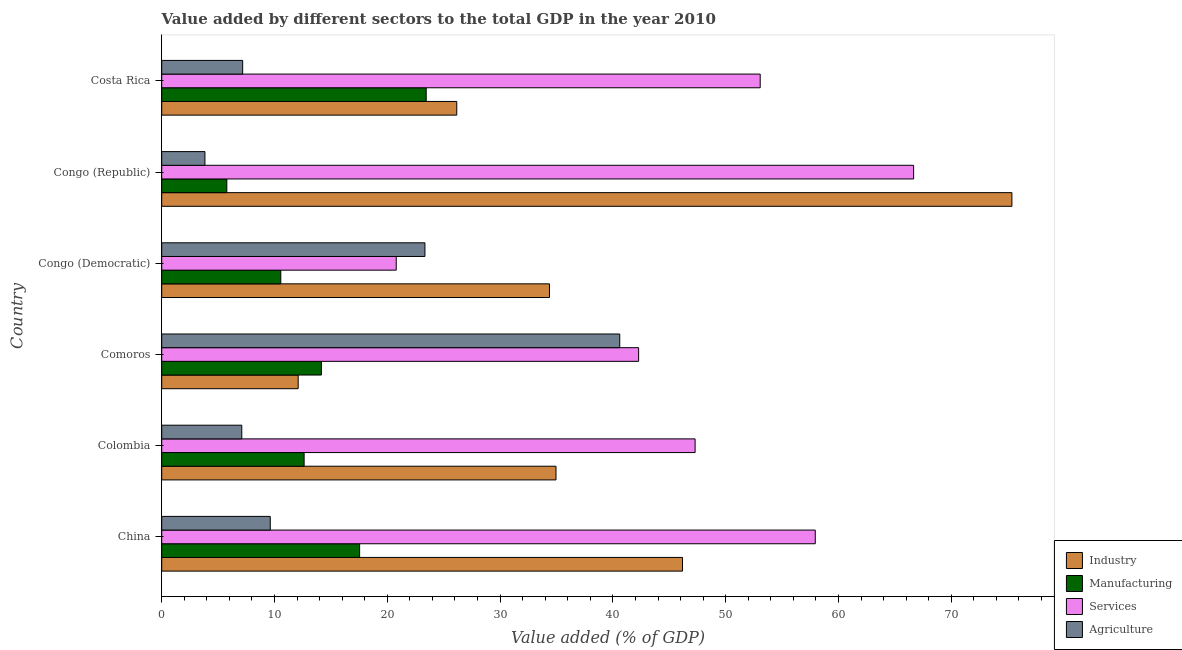Are the number of bars per tick equal to the number of legend labels?
Your answer should be compact. Yes. How many bars are there on the 4th tick from the bottom?
Provide a succinct answer. 4. What is the label of the 1st group of bars from the top?
Make the answer very short. Costa Rica. In how many cases, is the number of bars for a given country not equal to the number of legend labels?
Ensure brevity in your answer.  0. What is the value added by agricultural sector in China?
Offer a terse response. 9.62. Across all countries, what is the maximum value added by services sector?
Offer a terse response. 66.66. Across all countries, what is the minimum value added by services sector?
Your answer should be very brief. 20.79. In which country was the value added by industrial sector maximum?
Your answer should be compact. Congo (Republic). In which country was the value added by industrial sector minimum?
Ensure brevity in your answer.  Comoros. What is the total value added by manufacturing sector in the graph?
Make the answer very short. 84.11. What is the difference between the value added by agricultural sector in Colombia and that in Congo (Republic)?
Your answer should be compact. 3.27. What is the difference between the value added by services sector in China and the value added by agricultural sector in Comoros?
Your answer should be compact. 17.33. What is the average value added by services sector per country?
Offer a very short reply. 48.01. What is the difference between the value added by services sector and value added by industrial sector in Congo (Republic)?
Your answer should be very brief. -8.71. What is the ratio of the value added by industrial sector in Congo (Democratic) to that in Congo (Republic)?
Your answer should be compact. 0.46. Is the difference between the value added by industrial sector in Colombia and Congo (Republic) greater than the difference between the value added by services sector in Colombia and Congo (Republic)?
Offer a terse response. No. What is the difference between the highest and the second highest value added by industrial sector?
Offer a very short reply. 29.2. What is the difference between the highest and the lowest value added by agricultural sector?
Ensure brevity in your answer.  36.78. In how many countries, is the value added by industrial sector greater than the average value added by industrial sector taken over all countries?
Provide a short and direct response. 2. Is the sum of the value added by agricultural sector in Colombia and Comoros greater than the maximum value added by industrial sector across all countries?
Provide a succinct answer. No. What does the 3rd bar from the top in Colombia represents?
Your answer should be compact. Manufacturing. What does the 2nd bar from the bottom in Costa Rica represents?
Make the answer very short. Manufacturing. Is it the case that in every country, the sum of the value added by industrial sector and value added by manufacturing sector is greater than the value added by services sector?
Provide a short and direct response. No. How many countries are there in the graph?
Provide a succinct answer. 6. What is the difference between two consecutive major ticks on the X-axis?
Your response must be concise. 10. Are the values on the major ticks of X-axis written in scientific E-notation?
Offer a terse response. No. Does the graph contain grids?
Give a very brief answer. No. How many legend labels are there?
Your answer should be very brief. 4. How are the legend labels stacked?
Your answer should be very brief. Vertical. What is the title of the graph?
Provide a short and direct response. Value added by different sectors to the total GDP in the year 2010. Does "Taxes on goods and services" appear as one of the legend labels in the graph?
Keep it short and to the point. No. What is the label or title of the X-axis?
Your answer should be very brief. Value added (% of GDP). What is the Value added (% of GDP) of Industry in China?
Make the answer very short. 46.17. What is the Value added (% of GDP) of Manufacturing in China?
Give a very brief answer. 17.55. What is the Value added (% of GDP) of Services in China?
Offer a terse response. 57.94. What is the Value added (% of GDP) in Agriculture in China?
Provide a succinct answer. 9.62. What is the Value added (% of GDP) of Industry in Colombia?
Give a very brief answer. 34.96. What is the Value added (% of GDP) in Manufacturing in Colombia?
Your answer should be very brief. 12.63. What is the Value added (% of GDP) in Services in Colombia?
Your response must be concise. 47.29. What is the Value added (% of GDP) of Agriculture in Colombia?
Your answer should be very brief. 7.1. What is the Value added (% of GDP) in Industry in Comoros?
Provide a short and direct response. 12.1. What is the Value added (% of GDP) of Manufacturing in Comoros?
Your answer should be very brief. 14.16. What is the Value added (% of GDP) of Services in Comoros?
Provide a succinct answer. 42.28. What is the Value added (% of GDP) of Agriculture in Comoros?
Provide a succinct answer. 40.61. What is the Value added (% of GDP) of Industry in Congo (Democratic)?
Provide a succinct answer. 34.38. What is the Value added (% of GDP) of Manufacturing in Congo (Democratic)?
Your response must be concise. 10.56. What is the Value added (% of GDP) of Services in Congo (Democratic)?
Provide a short and direct response. 20.79. What is the Value added (% of GDP) in Agriculture in Congo (Democratic)?
Your answer should be very brief. 23.34. What is the Value added (% of GDP) of Industry in Congo (Republic)?
Make the answer very short. 75.38. What is the Value added (% of GDP) of Manufacturing in Congo (Republic)?
Provide a succinct answer. 5.77. What is the Value added (% of GDP) in Services in Congo (Republic)?
Provide a succinct answer. 66.66. What is the Value added (% of GDP) in Agriculture in Congo (Republic)?
Keep it short and to the point. 3.83. What is the Value added (% of GDP) in Industry in Costa Rica?
Give a very brief answer. 26.16. What is the Value added (% of GDP) of Manufacturing in Costa Rica?
Offer a very short reply. 23.45. What is the Value added (% of GDP) in Services in Costa Rica?
Your answer should be compact. 53.06. What is the Value added (% of GDP) in Agriculture in Costa Rica?
Your answer should be very brief. 7.18. Across all countries, what is the maximum Value added (% of GDP) of Industry?
Give a very brief answer. 75.38. Across all countries, what is the maximum Value added (% of GDP) in Manufacturing?
Make the answer very short. 23.45. Across all countries, what is the maximum Value added (% of GDP) in Services?
Keep it short and to the point. 66.66. Across all countries, what is the maximum Value added (% of GDP) in Agriculture?
Keep it short and to the point. 40.61. Across all countries, what is the minimum Value added (% of GDP) of Industry?
Offer a very short reply. 12.1. Across all countries, what is the minimum Value added (% of GDP) of Manufacturing?
Your response must be concise. 5.77. Across all countries, what is the minimum Value added (% of GDP) in Services?
Make the answer very short. 20.79. Across all countries, what is the minimum Value added (% of GDP) in Agriculture?
Your answer should be very brief. 3.83. What is the total Value added (% of GDP) of Industry in the graph?
Your answer should be very brief. 229.15. What is the total Value added (% of GDP) of Manufacturing in the graph?
Offer a very short reply. 84.11. What is the total Value added (% of GDP) of Services in the graph?
Your response must be concise. 288.04. What is the total Value added (% of GDP) in Agriculture in the graph?
Provide a succinct answer. 91.68. What is the difference between the Value added (% of GDP) of Industry in China and that in Colombia?
Keep it short and to the point. 11.22. What is the difference between the Value added (% of GDP) of Manufacturing in China and that in Colombia?
Make the answer very short. 4.92. What is the difference between the Value added (% of GDP) in Services in China and that in Colombia?
Make the answer very short. 10.65. What is the difference between the Value added (% of GDP) in Agriculture in China and that in Colombia?
Provide a succinct answer. 2.53. What is the difference between the Value added (% of GDP) of Industry in China and that in Comoros?
Provide a short and direct response. 34.07. What is the difference between the Value added (% of GDP) of Manufacturing in China and that in Comoros?
Keep it short and to the point. 3.39. What is the difference between the Value added (% of GDP) of Services in China and that in Comoros?
Your answer should be compact. 15.66. What is the difference between the Value added (% of GDP) of Agriculture in China and that in Comoros?
Your answer should be compact. -30.99. What is the difference between the Value added (% of GDP) of Industry in China and that in Congo (Democratic)?
Give a very brief answer. 11.79. What is the difference between the Value added (% of GDP) of Manufacturing in China and that in Congo (Democratic)?
Make the answer very short. 6.99. What is the difference between the Value added (% of GDP) of Services in China and that in Congo (Democratic)?
Provide a succinct answer. 37.15. What is the difference between the Value added (% of GDP) in Agriculture in China and that in Congo (Democratic)?
Your answer should be very brief. -13.71. What is the difference between the Value added (% of GDP) of Industry in China and that in Congo (Republic)?
Provide a succinct answer. -29.2. What is the difference between the Value added (% of GDP) in Manufacturing in China and that in Congo (Republic)?
Offer a very short reply. 11.77. What is the difference between the Value added (% of GDP) in Services in China and that in Congo (Republic)?
Your response must be concise. -8.72. What is the difference between the Value added (% of GDP) in Agriculture in China and that in Congo (Republic)?
Make the answer very short. 5.79. What is the difference between the Value added (% of GDP) in Industry in China and that in Costa Rica?
Give a very brief answer. 20.02. What is the difference between the Value added (% of GDP) in Manufacturing in China and that in Costa Rica?
Ensure brevity in your answer.  -5.9. What is the difference between the Value added (% of GDP) in Services in China and that in Costa Rica?
Provide a succinct answer. 4.88. What is the difference between the Value added (% of GDP) of Agriculture in China and that in Costa Rica?
Ensure brevity in your answer.  2.45. What is the difference between the Value added (% of GDP) in Industry in Colombia and that in Comoros?
Ensure brevity in your answer.  22.86. What is the difference between the Value added (% of GDP) of Manufacturing in Colombia and that in Comoros?
Provide a succinct answer. -1.53. What is the difference between the Value added (% of GDP) of Services in Colombia and that in Comoros?
Give a very brief answer. 5.01. What is the difference between the Value added (% of GDP) in Agriculture in Colombia and that in Comoros?
Ensure brevity in your answer.  -33.51. What is the difference between the Value added (% of GDP) of Industry in Colombia and that in Congo (Democratic)?
Your answer should be very brief. 0.58. What is the difference between the Value added (% of GDP) in Manufacturing in Colombia and that in Congo (Democratic)?
Offer a very short reply. 2.07. What is the difference between the Value added (% of GDP) in Services in Colombia and that in Congo (Democratic)?
Offer a very short reply. 26.5. What is the difference between the Value added (% of GDP) of Agriculture in Colombia and that in Congo (Democratic)?
Offer a terse response. -16.24. What is the difference between the Value added (% of GDP) in Industry in Colombia and that in Congo (Republic)?
Your response must be concise. -40.42. What is the difference between the Value added (% of GDP) of Manufacturing in Colombia and that in Congo (Republic)?
Ensure brevity in your answer.  6.85. What is the difference between the Value added (% of GDP) of Services in Colombia and that in Congo (Republic)?
Provide a short and direct response. -19.37. What is the difference between the Value added (% of GDP) of Agriculture in Colombia and that in Congo (Republic)?
Offer a terse response. 3.27. What is the difference between the Value added (% of GDP) of Industry in Colombia and that in Costa Rica?
Offer a terse response. 8.8. What is the difference between the Value added (% of GDP) of Manufacturing in Colombia and that in Costa Rica?
Ensure brevity in your answer.  -10.82. What is the difference between the Value added (% of GDP) of Services in Colombia and that in Costa Rica?
Keep it short and to the point. -5.77. What is the difference between the Value added (% of GDP) of Agriculture in Colombia and that in Costa Rica?
Offer a terse response. -0.08. What is the difference between the Value added (% of GDP) of Industry in Comoros and that in Congo (Democratic)?
Your answer should be compact. -22.28. What is the difference between the Value added (% of GDP) of Manufacturing in Comoros and that in Congo (Democratic)?
Your answer should be very brief. 3.6. What is the difference between the Value added (% of GDP) of Services in Comoros and that in Congo (Democratic)?
Keep it short and to the point. 21.49. What is the difference between the Value added (% of GDP) in Agriculture in Comoros and that in Congo (Democratic)?
Offer a very short reply. 17.27. What is the difference between the Value added (% of GDP) in Industry in Comoros and that in Congo (Republic)?
Ensure brevity in your answer.  -63.28. What is the difference between the Value added (% of GDP) in Manufacturing in Comoros and that in Congo (Republic)?
Keep it short and to the point. 8.38. What is the difference between the Value added (% of GDP) in Services in Comoros and that in Congo (Republic)?
Provide a succinct answer. -24.38. What is the difference between the Value added (% of GDP) in Agriculture in Comoros and that in Congo (Republic)?
Your answer should be very brief. 36.78. What is the difference between the Value added (% of GDP) of Industry in Comoros and that in Costa Rica?
Keep it short and to the point. -14.06. What is the difference between the Value added (% of GDP) of Manufacturing in Comoros and that in Costa Rica?
Your answer should be very brief. -9.29. What is the difference between the Value added (% of GDP) of Services in Comoros and that in Costa Rica?
Your response must be concise. -10.78. What is the difference between the Value added (% of GDP) in Agriculture in Comoros and that in Costa Rica?
Provide a short and direct response. 33.43. What is the difference between the Value added (% of GDP) in Industry in Congo (Democratic) and that in Congo (Republic)?
Provide a short and direct response. -41. What is the difference between the Value added (% of GDP) in Manufacturing in Congo (Democratic) and that in Congo (Republic)?
Give a very brief answer. 4.78. What is the difference between the Value added (% of GDP) in Services in Congo (Democratic) and that in Congo (Republic)?
Offer a very short reply. -45.87. What is the difference between the Value added (% of GDP) of Agriculture in Congo (Democratic) and that in Congo (Republic)?
Offer a very short reply. 19.51. What is the difference between the Value added (% of GDP) of Industry in Congo (Democratic) and that in Costa Rica?
Provide a short and direct response. 8.22. What is the difference between the Value added (% of GDP) in Manufacturing in Congo (Democratic) and that in Costa Rica?
Offer a very short reply. -12.89. What is the difference between the Value added (% of GDP) in Services in Congo (Democratic) and that in Costa Rica?
Your response must be concise. -32.27. What is the difference between the Value added (% of GDP) of Agriculture in Congo (Democratic) and that in Costa Rica?
Provide a succinct answer. 16.16. What is the difference between the Value added (% of GDP) in Industry in Congo (Republic) and that in Costa Rica?
Keep it short and to the point. 49.22. What is the difference between the Value added (% of GDP) of Manufacturing in Congo (Republic) and that in Costa Rica?
Your answer should be compact. -17.68. What is the difference between the Value added (% of GDP) in Services in Congo (Republic) and that in Costa Rica?
Make the answer very short. 13.6. What is the difference between the Value added (% of GDP) in Agriculture in Congo (Republic) and that in Costa Rica?
Your answer should be very brief. -3.35. What is the difference between the Value added (% of GDP) in Industry in China and the Value added (% of GDP) in Manufacturing in Colombia?
Offer a terse response. 33.55. What is the difference between the Value added (% of GDP) in Industry in China and the Value added (% of GDP) in Services in Colombia?
Provide a short and direct response. -1.12. What is the difference between the Value added (% of GDP) of Industry in China and the Value added (% of GDP) of Agriculture in Colombia?
Your answer should be compact. 39.08. What is the difference between the Value added (% of GDP) in Manufacturing in China and the Value added (% of GDP) in Services in Colombia?
Offer a terse response. -29.74. What is the difference between the Value added (% of GDP) in Manufacturing in China and the Value added (% of GDP) in Agriculture in Colombia?
Offer a very short reply. 10.45. What is the difference between the Value added (% of GDP) of Services in China and the Value added (% of GDP) of Agriculture in Colombia?
Ensure brevity in your answer.  50.85. What is the difference between the Value added (% of GDP) in Industry in China and the Value added (% of GDP) in Manufacturing in Comoros?
Offer a very short reply. 32.02. What is the difference between the Value added (% of GDP) of Industry in China and the Value added (% of GDP) of Services in Comoros?
Make the answer very short. 3.89. What is the difference between the Value added (% of GDP) in Industry in China and the Value added (% of GDP) in Agriculture in Comoros?
Provide a short and direct response. 5.56. What is the difference between the Value added (% of GDP) in Manufacturing in China and the Value added (% of GDP) in Services in Comoros?
Your answer should be compact. -24.73. What is the difference between the Value added (% of GDP) in Manufacturing in China and the Value added (% of GDP) in Agriculture in Comoros?
Provide a short and direct response. -23.06. What is the difference between the Value added (% of GDP) in Services in China and the Value added (% of GDP) in Agriculture in Comoros?
Give a very brief answer. 17.33. What is the difference between the Value added (% of GDP) in Industry in China and the Value added (% of GDP) in Manufacturing in Congo (Democratic)?
Make the answer very short. 35.62. What is the difference between the Value added (% of GDP) in Industry in China and the Value added (% of GDP) in Services in Congo (Democratic)?
Your answer should be compact. 25.38. What is the difference between the Value added (% of GDP) in Industry in China and the Value added (% of GDP) in Agriculture in Congo (Democratic)?
Give a very brief answer. 22.84. What is the difference between the Value added (% of GDP) in Manufacturing in China and the Value added (% of GDP) in Services in Congo (Democratic)?
Ensure brevity in your answer.  -3.25. What is the difference between the Value added (% of GDP) in Manufacturing in China and the Value added (% of GDP) in Agriculture in Congo (Democratic)?
Ensure brevity in your answer.  -5.79. What is the difference between the Value added (% of GDP) of Services in China and the Value added (% of GDP) of Agriculture in Congo (Democratic)?
Keep it short and to the point. 34.61. What is the difference between the Value added (% of GDP) in Industry in China and the Value added (% of GDP) in Manufacturing in Congo (Republic)?
Provide a succinct answer. 40.4. What is the difference between the Value added (% of GDP) in Industry in China and the Value added (% of GDP) in Services in Congo (Republic)?
Your answer should be compact. -20.49. What is the difference between the Value added (% of GDP) of Industry in China and the Value added (% of GDP) of Agriculture in Congo (Republic)?
Provide a succinct answer. 42.34. What is the difference between the Value added (% of GDP) in Manufacturing in China and the Value added (% of GDP) in Services in Congo (Republic)?
Provide a succinct answer. -49.12. What is the difference between the Value added (% of GDP) in Manufacturing in China and the Value added (% of GDP) in Agriculture in Congo (Republic)?
Provide a succinct answer. 13.72. What is the difference between the Value added (% of GDP) in Services in China and the Value added (% of GDP) in Agriculture in Congo (Republic)?
Your answer should be compact. 54.11. What is the difference between the Value added (% of GDP) of Industry in China and the Value added (% of GDP) of Manufacturing in Costa Rica?
Provide a short and direct response. 22.72. What is the difference between the Value added (% of GDP) in Industry in China and the Value added (% of GDP) in Services in Costa Rica?
Offer a very short reply. -6.89. What is the difference between the Value added (% of GDP) of Industry in China and the Value added (% of GDP) of Agriculture in Costa Rica?
Offer a terse response. 39. What is the difference between the Value added (% of GDP) of Manufacturing in China and the Value added (% of GDP) of Services in Costa Rica?
Your answer should be compact. -35.52. What is the difference between the Value added (% of GDP) of Manufacturing in China and the Value added (% of GDP) of Agriculture in Costa Rica?
Give a very brief answer. 10.37. What is the difference between the Value added (% of GDP) of Services in China and the Value added (% of GDP) of Agriculture in Costa Rica?
Ensure brevity in your answer.  50.77. What is the difference between the Value added (% of GDP) of Industry in Colombia and the Value added (% of GDP) of Manufacturing in Comoros?
Provide a succinct answer. 20.8. What is the difference between the Value added (% of GDP) of Industry in Colombia and the Value added (% of GDP) of Services in Comoros?
Offer a very short reply. -7.32. What is the difference between the Value added (% of GDP) of Industry in Colombia and the Value added (% of GDP) of Agriculture in Comoros?
Your answer should be very brief. -5.65. What is the difference between the Value added (% of GDP) of Manufacturing in Colombia and the Value added (% of GDP) of Services in Comoros?
Offer a very short reply. -29.66. What is the difference between the Value added (% of GDP) of Manufacturing in Colombia and the Value added (% of GDP) of Agriculture in Comoros?
Your response must be concise. -27.98. What is the difference between the Value added (% of GDP) of Services in Colombia and the Value added (% of GDP) of Agriculture in Comoros?
Provide a short and direct response. 6.68. What is the difference between the Value added (% of GDP) in Industry in Colombia and the Value added (% of GDP) in Manufacturing in Congo (Democratic)?
Your answer should be compact. 24.4. What is the difference between the Value added (% of GDP) of Industry in Colombia and the Value added (% of GDP) of Services in Congo (Democratic)?
Keep it short and to the point. 14.17. What is the difference between the Value added (% of GDP) of Industry in Colombia and the Value added (% of GDP) of Agriculture in Congo (Democratic)?
Make the answer very short. 11.62. What is the difference between the Value added (% of GDP) of Manufacturing in Colombia and the Value added (% of GDP) of Services in Congo (Democratic)?
Your answer should be very brief. -8.17. What is the difference between the Value added (% of GDP) in Manufacturing in Colombia and the Value added (% of GDP) in Agriculture in Congo (Democratic)?
Ensure brevity in your answer.  -10.71. What is the difference between the Value added (% of GDP) of Services in Colombia and the Value added (% of GDP) of Agriculture in Congo (Democratic)?
Keep it short and to the point. 23.95. What is the difference between the Value added (% of GDP) in Industry in Colombia and the Value added (% of GDP) in Manufacturing in Congo (Republic)?
Provide a succinct answer. 29.18. What is the difference between the Value added (% of GDP) in Industry in Colombia and the Value added (% of GDP) in Services in Congo (Republic)?
Ensure brevity in your answer.  -31.71. What is the difference between the Value added (% of GDP) of Industry in Colombia and the Value added (% of GDP) of Agriculture in Congo (Republic)?
Offer a very short reply. 31.13. What is the difference between the Value added (% of GDP) in Manufacturing in Colombia and the Value added (% of GDP) in Services in Congo (Republic)?
Keep it short and to the point. -54.04. What is the difference between the Value added (% of GDP) of Manufacturing in Colombia and the Value added (% of GDP) of Agriculture in Congo (Republic)?
Your answer should be compact. 8.8. What is the difference between the Value added (% of GDP) in Services in Colombia and the Value added (% of GDP) in Agriculture in Congo (Republic)?
Give a very brief answer. 43.46. What is the difference between the Value added (% of GDP) of Industry in Colombia and the Value added (% of GDP) of Manufacturing in Costa Rica?
Provide a succinct answer. 11.51. What is the difference between the Value added (% of GDP) of Industry in Colombia and the Value added (% of GDP) of Services in Costa Rica?
Make the answer very short. -18.1. What is the difference between the Value added (% of GDP) of Industry in Colombia and the Value added (% of GDP) of Agriculture in Costa Rica?
Provide a short and direct response. 27.78. What is the difference between the Value added (% of GDP) of Manufacturing in Colombia and the Value added (% of GDP) of Services in Costa Rica?
Your answer should be very brief. -40.44. What is the difference between the Value added (% of GDP) in Manufacturing in Colombia and the Value added (% of GDP) in Agriculture in Costa Rica?
Provide a succinct answer. 5.45. What is the difference between the Value added (% of GDP) of Services in Colombia and the Value added (% of GDP) of Agriculture in Costa Rica?
Make the answer very short. 40.11. What is the difference between the Value added (% of GDP) of Industry in Comoros and the Value added (% of GDP) of Manufacturing in Congo (Democratic)?
Provide a short and direct response. 1.54. What is the difference between the Value added (% of GDP) in Industry in Comoros and the Value added (% of GDP) in Services in Congo (Democratic)?
Give a very brief answer. -8.69. What is the difference between the Value added (% of GDP) of Industry in Comoros and the Value added (% of GDP) of Agriculture in Congo (Democratic)?
Offer a terse response. -11.24. What is the difference between the Value added (% of GDP) in Manufacturing in Comoros and the Value added (% of GDP) in Services in Congo (Democratic)?
Offer a terse response. -6.64. What is the difference between the Value added (% of GDP) of Manufacturing in Comoros and the Value added (% of GDP) of Agriculture in Congo (Democratic)?
Your answer should be very brief. -9.18. What is the difference between the Value added (% of GDP) of Services in Comoros and the Value added (% of GDP) of Agriculture in Congo (Democratic)?
Make the answer very short. 18.94. What is the difference between the Value added (% of GDP) of Industry in Comoros and the Value added (% of GDP) of Manufacturing in Congo (Republic)?
Your answer should be compact. 6.33. What is the difference between the Value added (% of GDP) in Industry in Comoros and the Value added (% of GDP) in Services in Congo (Republic)?
Give a very brief answer. -54.56. What is the difference between the Value added (% of GDP) in Industry in Comoros and the Value added (% of GDP) in Agriculture in Congo (Republic)?
Your answer should be compact. 8.27. What is the difference between the Value added (% of GDP) of Manufacturing in Comoros and the Value added (% of GDP) of Services in Congo (Republic)?
Your answer should be very brief. -52.51. What is the difference between the Value added (% of GDP) in Manufacturing in Comoros and the Value added (% of GDP) in Agriculture in Congo (Republic)?
Ensure brevity in your answer.  10.33. What is the difference between the Value added (% of GDP) of Services in Comoros and the Value added (% of GDP) of Agriculture in Congo (Republic)?
Your response must be concise. 38.45. What is the difference between the Value added (% of GDP) of Industry in Comoros and the Value added (% of GDP) of Manufacturing in Costa Rica?
Give a very brief answer. -11.35. What is the difference between the Value added (% of GDP) in Industry in Comoros and the Value added (% of GDP) in Services in Costa Rica?
Offer a terse response. -40.96. What is the difference between the Value added (% of GDP) of Industry in Comoros and the Value added (% of GDP) of Agriculture in Costa Rica?
Give a very brief answer. 4.92. What is the difference between the Value added (% of GDP) of Manufacturing in Comoros and the Value added (% of GDP) of Services in Costa Rica?
Provide a succinct answer. -38.91. What is the difference between the Value added (% of GDP) in Manufacturing in Comoros and the Value added (% of GDP) in Agriculture in Costa Rica?
Offer a very short reply. 6.98. What is the difference between the Value added (% of GDP) of Services in Comoros and the Value added (% of GDP) of Agriculture in Costa Rica?
Your response must be concise. 35.1. What is the difference between the Value added (% of GDP) in Industry in Congo (Democratic) and the Value added (% of GDP) in Manufacturing in Congo (Republic)?
Make the answer very short. 28.61. What is the difference between the Value added (% of GDP) in Industry in Congo (Democratic) and the Value added (% of GDP) in Services in Congo (Republic)?
Your answer should be compact. -32.28. What is the difference between the Value added (% of GDP) in Industry in Congo (Democratic) and the Value added (% of GDP) in Agriculture in Congo (Republic)?
Ensure brevity in your answer.  30.55. What is the difference between the Value added (% of GDP) in Manufacturing in Congo (Democratic) and the Value added (% of GDP) in Services in Congo (Republic)?
Your answer should be compact. -56.11. What is the difference between the Value added (% of GDP) in Manufacturing in Congo (Democratic) and the Value added (% of GDP) in Agriculture in Congo (Republic)?
Your answer should be very brief. 6.73. What is the difference between the Value added (% of GDP) of Services in Congo (Democratic) and the Value added (% of GDP) of Agriculture in Congo (Republic)?
Keep it short and to the point. 16.96. What is the difference between the Value added (% of GDP) of Industry in Congo (Democratic) and the Value added (% of GDP) of Manufacturing in Costa Rica?
Give a very brief answer. 10.93. What is the difference between the Value added (% of GDP) in Industry in Congo (Democratic) and the Value added (% of GDP) in Services in Costa Rica?
Ensure brevity in your answer.  -18.68. What is the difference between the Value added (% of GDP) in Industry in Congo (Democratic) and the Value added (% of GDP) in Agriculture in Costa Rica?
Give a very brief answer. 27.2. What is the difference between the Value added (% of GDP) of Manufacturing in Congo (Democratic) and the Value added (% of GDP) of Services in Costa Rica?
Give a very brief answer. -42.5. What is the difference between the Value added (% of GDP) of Manufacturing in Congo (Democratic) and the Value added (% of GDP) of Agriculture in Costa Rica?
Ensure brevity in your answer.  3.38. What is the difference between the Value added (% of GDP) of Services in Congo (Democratic) and the Value added (% of GDP) of Agriculture in Costa Rica?
Provide a succinct answer. 13.61. What is the difference between the Value added (% of GDP) in Industry in Congo (Republic) and the Value added (% of GDP) in Manufacturing in Costa Rica?
Your response must be concise. 51.93. What is the difference between the Value added (% of GDP) of Industry in Congo (Republic) and the Value added (% of GDP) of Services in Costa Rica?
Offer a terse response. 22.31. What is the difference between the Value added (% of GDP) in Industry in Congo (Republic) and the Value added (% of GDP) in Agriculture in Costa Rica?
Your answer should be compact. 68.2. What is the difference between the Value added (% of GDP) of Manufacturing in Congo (Republic) and the Value added (% of GDP) of Services in Costa Rica?
Give a very brief answer. -47.29. What is the difference between the Value added (% of GDP) of Manufacturing in Congo (Republic) and the Value added (% of GDP) of Agriculture in Costa Rica?
Provide a succinct answer. -1.4. What is the difference between the Value added (% of GDP) of Services in Congo (Republic) and the Value added (% of GDP) of Agriculture in Costa Rica?
Your answer should be very brief. 59.49. What is the average Value added (% of GDP) of Industry per country?
Your answer should be compact. 38.19. What is the average Value added (% of GDP) of Manufacturing per country?
Give a very brief answer. 14.02. What is the average Value added (% of GDP) of Services per country?
Make the answer very short. 48.01. What is the average Value added (% of GDP) in Agriculture per country?
Keep it short and to the point. 15.28. What is the difference between the Value added (% of GDP) of Industry and Value added (% of GDP) of Manufacturing in China?
Give a very brief answer. 28.63. What is the difference between the Value added (% of GDP) of Industry and Value added (% of GDP) of Services in China?
Ensure brevity in your answer.  -11.77. What is the difference between the Value added (% of GDP) of Industry and Value added (% of GDP) of Agriculture in China?
Make the answer very short. 36.55. What is the difference between the Value added (% of GDP) of Manufacturing and Value added (% of GDP) of Services in China?
Keep it short and to the point. -40.4. What is the difference between the Value added (% of GDP) in Manufacturing and Value added (% of GDP) in Agriculture in China?
Ensure brevity in your answer.  7.92. What is the difference between the Value added (% of GDP) of Services and Value added (% of GDP) of Agriculture in China?
Your answer should be very brief. 48.32. What is the difference between the Value added (% of GDP) of Industry and Value added (% of GDP) of Manufacturing in Colombia?
Provide a short and direct response. 22.33. What is the difference between the Value added (% of GDP) of Industry and Value added (% of GDP) of Services in Colombia?
Your answer should be very brief. -12.33. What is the difference between the Value added (% of GDP) of Industry and Value added (% of GDP) of Agriculture in Colombia?
Your answer should be compact. 27.86. What is the difference between the Value added (% of GDP) of Manufacturing and Value added (% of GDP) of Services in Colombia?
Give a very brief answer. -34.66. What is the difference between the Value added (% of GDP) of Manufacturing and Value added (% of GDP) of Agriculture in Colombia?
Ensure brevity in your answer.  5.53. What is the difference between the Value added (% of GDP) in Services and Value added (% of GDP) in Agriculture in Colombia?
Make the answer very short. 40.19. What is the difference between the Value added (% of GDP) of Industry and Value added (% of GDP) of Manufacturing in Comoros?
Your response must be concise. -2.06. What is the difference between the Value added (% of GDP) in Industry and Value added (% of GDP) in Services in Comoros?
Provide a succinct answer. -30.18. What is the difference between the Value added (% of GDP) in Industry and Value added (% of GDP) in Agriculture in Comoros?
Give a very brief answer. -28.51. What is the difference between the Value added (% of GDP) in Manufacturing and Value added (% of GDP) in Services in Comoros?
Your answer should be compact. -28.12. What is the difference between the Value added (% of GDP) in Manufacturing and Value added (% of GDP) in Agriculture in Comoros?
Ensure brevity in your answer.  -26.45. What is the difference between the Value added (% of GDP) of Services and Value added (% of GDP) of Agriculture in Comoros?
Keep it short and to the point. 1.67. What is the difference between the Value added (% of GDP) in Industry and Value added (% of GDP) in Manufacturing in Congo (Democratic)?
Your answer should be very brief. 23.82. What is the difference between the Value added (% of GDP) in Industry and Value added (% of GDP) in Services in Congo (Democratic)?
Keep it short and to the point. 13.59. What is the difference between the Value added (% of GDP) of Industry and Value added (% of GDP) of Agriculture in Congo (Democratic)?
Your response must be concise. 11.04. What is the difference between the Value added (% of GDP) of Manufacturing and Value added (% of GDP) of Services in Congo (Democratic)?
Ensure brevity in your answer.  -10.23. What is the difference between the Value added (% of GDP) in Manufacturing and Value added (% of GDP) in Agriculture in Congo (Democratic)?
Provide a short and direct response. -12.78. What is the difference between the Value added (% of GDP) in Services and Value added (% of GDP) in Agriculture in Congo (Democratic)?
Ensure brevity in your answer.  -2.55. What is the difference between the Value added (% of GDP) of Industry and Value added (% of GDP) of Manufacturing in Congo (Republic)?
Offer a very short reply. 69.6. What is the difference between the Value added (% of GDP) in Industry and Value added (% of GDP) in Services in Congo (Republic)?
Provide a short and direct response. 8.71. What is the difference between the Value added (% of GDP) in Industry and Value added (% of GDP) in Agriculture in Congo (Republic)?
Provide a succinct answer. 71.55. What is the difference between the Value added (% of GDP) in Manufacturing and Value added (% of GDP) in Services in Congo (Republic)?
Offer a very short reply. -60.89. What is the difference between the Value added (% of GDP) of Manufacturing and Value added (% of GDP) of Agriculture in Congo (Republic)?
Make the answer very short. 1.94. What is the difference between the Value added (% of GDP) in Services and Value added (% of GDP) in Agriculture in Congo (Republic)?
Offer a terse response. 62.83. What is the difference between the Value added (% of GDP) in Industry and Value added (% of GDP) in Manufacturing in Costa Rica?
Your answer should be compact. 2.71. What is the difference between the Value added (% of GDP) of Industry and Value added (% of GDP) of Services in Costa Rica?
Your response must be concise. -26.9. What is the difference between the Value added (% of GDP) in Industry and Value added (% of GDP) in Agriculture in Costa Rica?
Offer a terse response. 18.98. What is the difference between the Value added (% of GDP) of Manufacturing and Value added (% of GDP) of Services in Costa Rica?
Provide a succinct answer. -29.61. What is the difference between the Value added (% of GDP) of Manufacturing and Value added (% of GDP) of Agriculture in Costa Rica?
Make the answer very short. 16.27. What is the difference between the Value added (% of GDP) of Services and Value added (% of GDP) of Agriculture in Costa Rica?
Your response must be concise. 45.88. What is the ratio of the Value added (% of GDP) in Industry in China to that in Colombia?
Provide a short and direct response. 1.32. What is the ratio of the Value added (% of GDP) of Manufacturing in China to that in Colombia?
Give a very brief answer. 1.39. What is the ratio of the Value added (% of GDP) of Services in China to that in Colombia?
Give a very brief answer. 1.23. What is the ratio of the Value added (% of GDP) in Agriculture in China to that in Colombia?
Keep it short and to the point. 1.36. What is the ratio of the Value added (% of GDP) of Industry in China to that in Comoros?
Your response must be concise. 3.82. What is the ratio of the Value added (% of GDP) in Manufacturing in China to that in Comoros?
Provide a short and direct response. 1.24. What is the ratio of the Value added (% of GDP) of Services in China to that in Comoros?
Offer a terse response. 1.37. What is the ratio of the Value added (% of GDP) of Agriculture in China to that in Comoros?
Your response must be concise. 0.24. What is the ratio of the Value added (% of GDP) of Industry in China to that in Congo (Democratic)?
Keep it short and to the point. 1.34. What is the ratio of the Value added (% of GDP) in Manufacturing in China to that in Congo (Democratic)?
Offer a terse response. 1.66. What is the ratio of the Value added (% of GDP) of Services in China to that in Congo (Democratic)?
Provide a succinct answer. 2.79. What is the ratio of the Value added (% of GDP) in Agriculture in China to that in Congo (Democratic)?
Make the answer very short. 0.41. What is the ratio of the Value added (% of GDP) in Industry in China to that in Congo (Republic)?
Your response must be concise. 0.61. What is the ratio of the Value added (% of GDP) of Manufacturing in China to that in Congo (Republic)?
Ensure brevity in your answer.  3.04. What is the ratio of the Value added (% of GDP) of Services in China to that in Congo (Republic)?
Give a very brief answer. 0.87. What is the ratio of the Value added (% of GDP) in Agriculture in China to that in Congo (Republic)?
Offer a very short reply. 2.51. What is the ratio of the Value added (% of GDP) in Industry in China to that in Costa Rica?
Your answer should be very brief. 1.77. What is the ratio of the Value added (% of GDP) of Manufacturing in China to that in Costa Rica?
Your answer should be compact. 0.75. What is the ratio of the Value added (% of GDP) of Services in China to that in Costa Rica?
Your answer should be very brief. 1.09. What is the ratio of the Value added (% of GDP) of Agriculture in China to that in Costa Rica?
Give a very brief answer. 1.34. What is the ratio of the Value added (% of GDP) in Industry in Colombia to that in Comoros?
Give a very brief answer. 2.89. What is the ratio of the Value added (% of GDP) of Manufacturing in Colombia to that in Comoros?
Your answer should be very brief. 0.89. What is the ratio of the Value added (% of GDP) in Services in Colombia to that in Comoros?
Your answer should be compact. 1.12. What is the ratio of the Value added (% of GDP) in Agriculture in Colombia to that in Comoros?
Your answer should be compact. 0.17. What is the ratio of the Value added (% of GDP) of Industry in Colombia to that in Congo (Democratic)?
Your response must be concise. 1.02. What is the ratio of the Value added (% of GDP) in Manufacturing in Colombia to that in Congo (Democratic)?
Keep it short and to the point. 1.2. What is the ratio of the Value added (% of GDP) of Services in Colombia to that in Congo (Democratic)?
Give a very brief answer. 2.27. What is the ratio of the Value added (% of GDP) of Agriculture in Colombia to that in Congo (Democratic)?
Offer a very short reply. 0.3. What is the ratio of the Value added (% of GDP) in Industry in Colombia to that in Congo (Republic)?
Your answer should be very brief. 0.46. What is the ratio of the Value added (% of GDP) of Manufacturing in Colombia to that in Congo (Republic)?
Keep it short and to the point. 2.19. What is the ratio of the Value added (% of GDP) in Services in Colombia to that in Congo (Republic)?
Offer a terse response. 0.71. What is the ratio of the Value added (% of GDP) in Agriculture in Colombia to that in Congo (Republic)?
Provide a short and direct response. 1.85. What is the ratio of the Value added (% of GDP) in Industry in Colombia to that in Costa Rica?
Provide a short and direct response. 1.34. What is the ratio of the Value added (% of GDP) of Manufacturing in Colombia to that in Costa Rica?
Provide a short and direct response. 0.54. What is the ratio of the Value added (% of GDP) in Services in Colombia to that in Costa Rica?
Your answer should be compact. 0.89. What is the ratio of the Value added (% of GDP) in Agriculture in Colombia to that in Costa Rica?
Your response must be concise. 0.99. What is the ratio of the Value added (% of GDP) in Industry in Comoros to that in Congo (Democratic)?
Give a very brief answer. 0.35. What is the ratio of the Value added (% of GDP) in Manufacturing in Comoros to that in Congo (Democratic)?
Provide a short and direct response. 1.34. What is the ratio of the Value added (% of GDP) of Services in Comoros to that in Congo (Democratic)?
Ensure brevity in your answer.  2.03. What is the ratio of the Value added (% of GDP) in Agriculture in Comoros to that in Congo (Democratic)?
Provide a short and direct response. 1.74. What is the ratio of the Value added (% of GDP) in Industry in Comoros to that in Congo (Republic)?
Your answer should be compact. 0.16. What is the ratio of the Value added (% of GDP) in Manufacturing in Comoros to that in Congo (Republic)?
Your response must be concise. 2.45. What is the ratio of the Value added (% of GDP) of Services in Comoros to that in Congo (Republic)?
Your response must be concise. 0.63. What is the ratio of the Value added (% of GDP) of Agriculture in Comoros to that in Congo (Republic)?
Ensure brevity in your answer.  10.6. What is the ratio of the Value added (% of GDP) in Industry in Comoros to that in Costa Rica?
Your answer should be compact. 0.46. What is the ratio of the Value added (% of GDP) in Manufacturing in Comoros to that in Costa Rica?
Your answer should be very brief. 0.6. What is the ratio of the Value added (% of GDP) of Services in Comoros to that in Costa Rica?
Your answer should be very brief. 0.8. What is the ratio of the Value added (% of GDP) in Agriculture in Comoros to that in Costa Rica?
Offer a very short reply. 5.66. What is the ratio of the Value added (% of GDP) in Industry in Congo (Democratic) to that in Congo (Republic)?
Make the answer very short. 0.46. What is the ratio of the Value added (% of GDP) of Manufacturing in Congo (Democratic) to that in Congo (Republic)?
Provide a succinct answer. 1.83. What is the ratio of the Value added (% of GDP) in Services in Congo (Democratic) to that in Congo (Republic)?
Provide a succinct answer. 0.31. What is the ratio of the Value added (% of GDP) in Agriculture in Congo (Democratic) to that in Congo (Republic)?
Offer a terse response. 6.09. What is the ratio of the Value added (% of GDP) in Industry in Congo (Democratic) to that in Costa Rica?
Offer a terse response. 1.31. What is the ratio of the Value added (% of GDP) in Manufacturing in Congo (Democratic) to that in Costa Rica?
Provide a short and direct response. 0.45. What is the ratio of the Value added (% of GDP) in Services in Congo (Democratic) to that in Costa Rica?
Your response must be concise. 0.39. What is the ratio of the Value added (% of GDP) in Agriculture in Congo (Democratic) to that in Costa Rica?
Offer a very short reply. 3.25. What is the ratio of the Value added (% of GDP) of Industry in Congo (Republic) to that in Costa Rica?
Offer a very short reply. 2.88. What is the ratio of the Value added (% of GDP) of Manufacturing in Congo (Republic) to that in Costa Rica?
Give a very brief answer. 0.25. What is the ratio of the Value added (% of GDP) of Services in Congo (Republic) to that in Costa Rica?
Your answer should be compact. 1.26. What is the ratio of the Value added (% of GDP) in Agriculture in Congo (Republic) to that in Costa Rica?
Make the answer very short. 0.53. What is the difference between the highest and the second highest Value added (% of GDP) in Industry?
Ensure brevity in your answer.  29.2. What is the difference between the highest and the second highest Value added (% of GDP) of Manufacturing?
Provide a short and direct response. 5.9. What is the difference between the highest and the second highest Value added (% of GDP) in Services?
Your answer should be compact. 8.72. What is the difference between the highest and the second highest Value added (% of GDP) of Agriculture?
Make the answer very short. 17.27. What is the difference between the highest and the lowest Value added (% of GDP) of Industry?
Your response must be concise. 63.28. What is the difference between the highest and the lowest Value added (% of GDP) of Manufacturing?
Your response must be concise. 17.68. What is the difference between the highest and the lowest Value added (% of GDP) of Services?
Offer a terse response. 45.87. What is the difference between the highest and the lowest Value added (% of GDP) in Agriculture?
Keep it short and to the point. 36.78. 